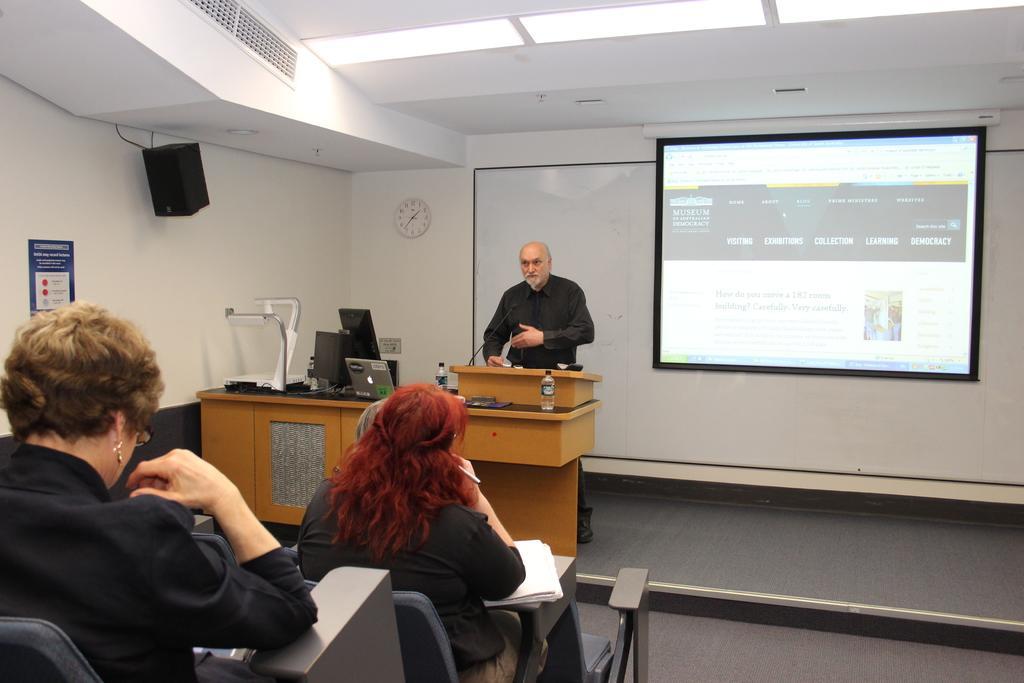Could you give a brief overview of what you see in this image? It seems to be of conference hall. Two women sat on chair. There is an old man stood in front of desk,which has laptop on it. On to the left side of wall,there is speaker. To the background wall there is clock and a screen. And to the roof there are ceiling lights and ac vents. 